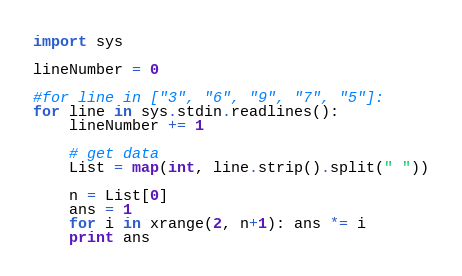Convert code to text. <code><loc_0><loc_0><loc_500><loc_500><_Python_>

import sys

lineNumber = 0

#for line in ["3", "6", "9", "7", "5"]:
for line in sys.stdin.readlines():
    lineNumber += 1

    # get data
    List = map(int, line.strip().split(" "))

    n = List[0]
    ans = 1
    for i in xrange(2, n+1): ans *= i
    print ans</code> 